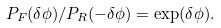Convert formula to latex. <formula><loc_0><loc_0><loc_500><loc_500>P _ { F } ( \delta \phi ) / P _ { R } ( - \delta \phi ) = \exp ( \delta \phi ) .</formula> 